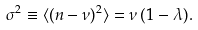Convert formula to latex. <formula><loc_0><loc_0><loc_500><loc_500>\sigma ^ { 2 } \equiv \langle ( n - \nu ) ^ { 2 } \rangle = \nu \, ( 1 - \lambda ) .</formula> 